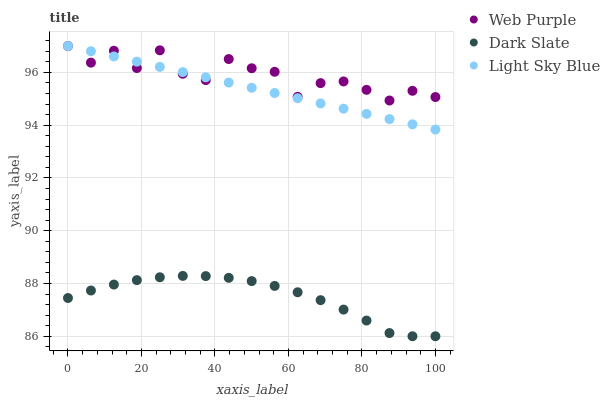Does Dark Slate have the minimum area under the curve?
Answer yes or no. Yes. Does Web Purple have the maximum area under the curve?
Answer yes or no. Yes. Does Light Sky Blue have the minimum area under the curve?
Answer yes or no. No. Does Light Sky Blue have the maximum area under the curve?
Answer yes or no. No. Is Light Sky Blue the smoothest?
Answer yes or no. Yes. Is Web Purple the roughest?
Answer yes or no. Yes. Is Web Purple the smoothest?
Answer yes or no. No. Is Light Sky Blue the roughest?
Answer yes or no. No. Does Dark Slate have the lowest value?
Answer yes or no. Yes. Does Light Sky Blue have the lowest value?
Answer yes or no. No. Does Light Sky Blue have the highest value?
Answer yes or no. Yes. Is Dark Slate less than Light Sky Blue?
Answer yes or no. Yes. Is Light Sky Blue greater than Dark Slate?
Answer yes or no. Yes. Does Web Purple intersect Light Sky Blue?
Answer yes or no. Yes. Is Web Purple less than Light Sky Blue?
Answer yes or no. No. Is Web Purple greater than Light Sky Blue?
Answer yes or no. No. Does Dark Slate intersect Light Sky Blue?
Answer yes or no. No. 